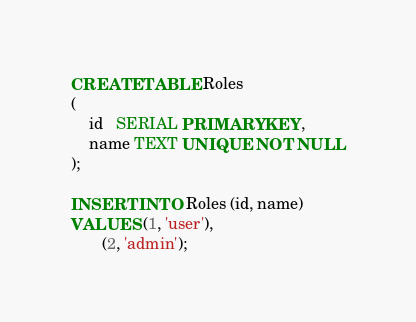Convert code to text. <code><loc_0><loc_0><loc_500><loc_500><_SQL_>CREATE TABLE Roles
(
    id   SERIAL PRIMARY KEY,
    name TEXT UNIQUE NOT NULL
);

INSERT INTO Roles (id, name)
VALUES (1, 'user'),
       (2, 'admin');
</code> 